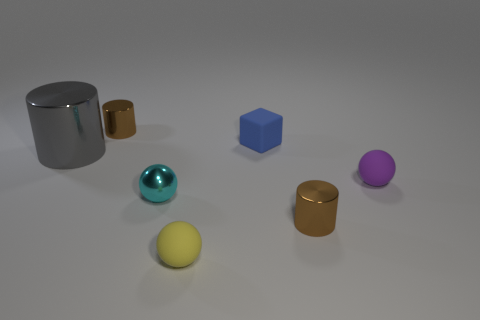Subtract all red balls. Subtract all yellow blocks. How many balls are left? 3 Add 2 small brown balls. How many objects exist? 9 Subtract all cylinders. How many objects are left? 4 Add 4 large gray metallic cylinders. How many large gray metallic cylinders are left? 5 Add 6 small rubber objects. How many small rubber objects exist? 9 Subtract 1 purple spheres. How many objects are left? 6 Subtract all large green objects. Subtract all gray objects. How many objects are left? 6 